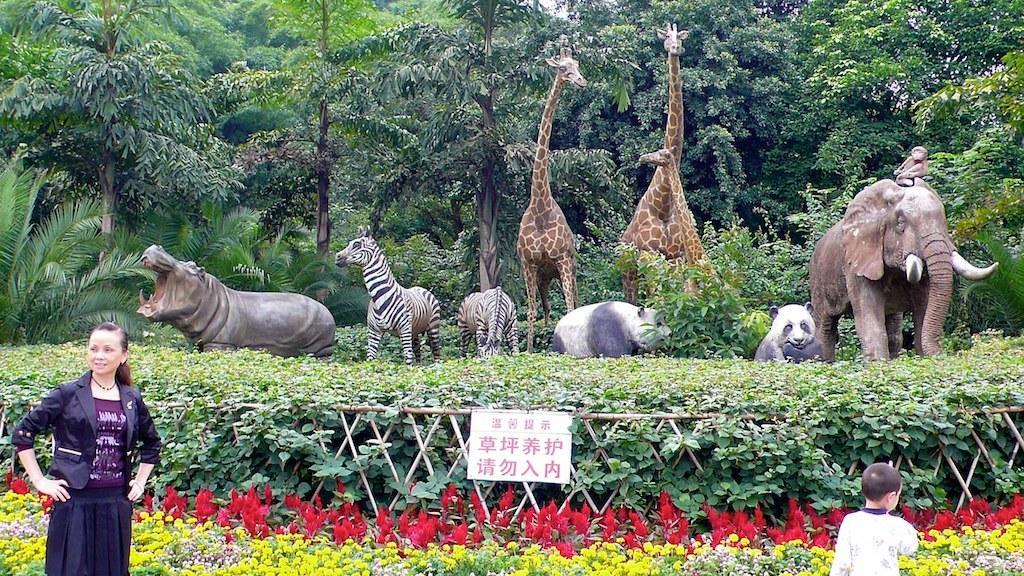Can you describe this image briefly? In the background we can see the trees. In this picture we can see the animals, plants, wooden fence and a board. We can see a woman is standing on the left side of the picture and a boy is standing on the right side of the picture. At the bottom portion of the picture we can see the colorful flowers. 